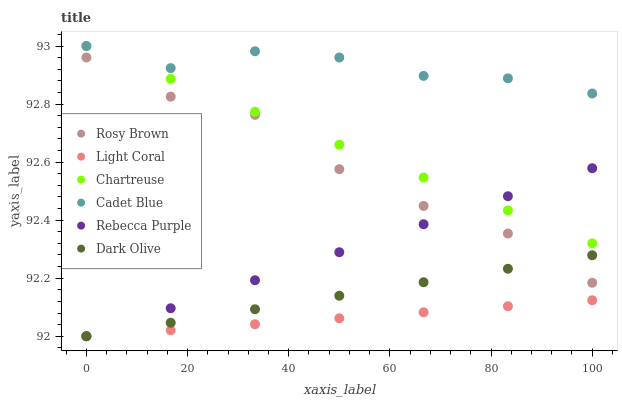Does Light Coral have the minimum area under the curve?
Answer yes or no. Yes. Does Cadet Blue have the maximum area under the curve?
Answer yes or no. Yes. Does Dark Olive have the minimum area under the curve?
Answer yes or no. No. Does Dark Olive have the maximum area under the curve?
Answer yes or no. No. Is Dark Olive the smoothest?
Answer yes or no. Yes. Is Rosy Brown the roughest?
Answer yes or no. Yes. Is Rosy Brown the smoothest?
Answer yes or no. No. Is Dark Olive the roughest?
Answer yes or no. No. Does Dark Olive have the lowest value?
Answer yes or no. Yes. Does Rosy Brown have the lowest value?
Answer yes or no. No. Does Chartreuse have the highest value?
Answer yes or no. Yes. Does Dark Olive have the highest value?
Answer yes or no. No. Is Rebecca Purple less than Cadet Blue?
Answer yes or no. Yes. Is Cadet Blue greater than Dark Olive?
Answer yes or no. Yes. Does Dark Olive intersect Light Coral?
Answer yes or no. Yes. Is Dark Olive less than Light Coral?
Answer yes or no. No. Is Dark Olive greater than Light Coral?
Answer yes or no. No. Does Rebecca Purple intersect Cadet Blue?
Answer yes or no. No. 